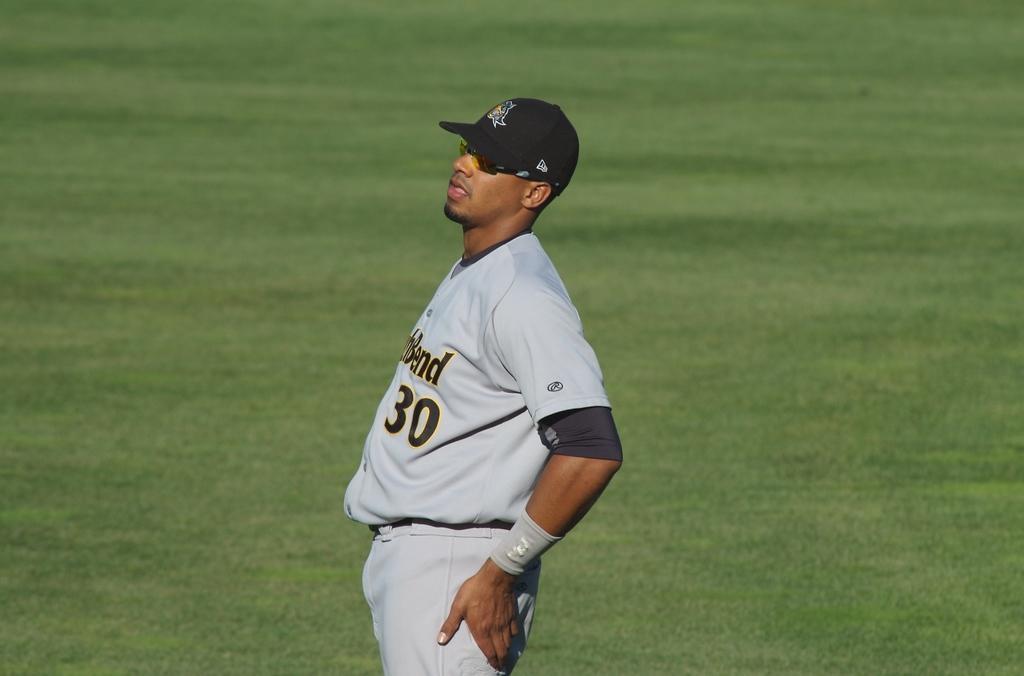Describe this image in one or two sentences. Here I can see a man wearing a white color t-shirt, cap and standing facing towards the left side. In the background, I can see the grass on the ground. 